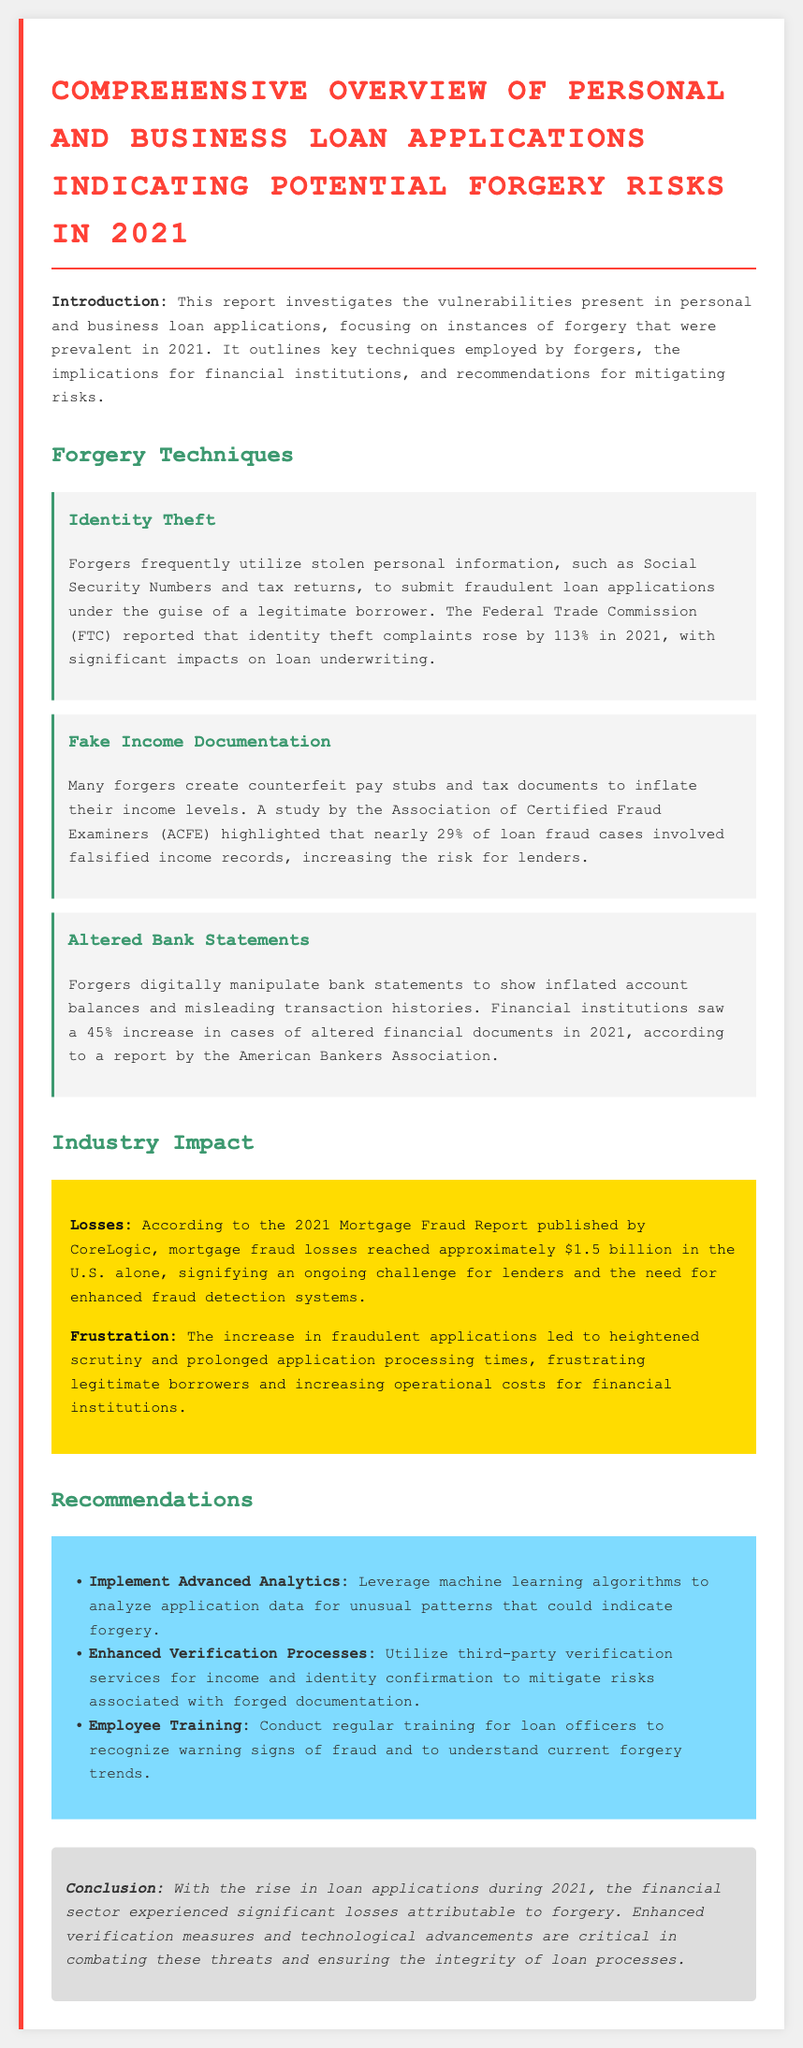What is the title of the report? The title is stated in the document as "Comprehensive Overview of Personal and Business Loan Applications Indicating Potential Forgery Risks in 2021."
Answer: Comprehensive Overview of Personal and Business Loan Applications Indicating Potential Forgery Risks in 2021 What percentage of loan fraud cases involved falsified income records? The report states that nearly 29% of loan fraud cases involved falsified income records according to a study by the Association of Certified Fraud Examiners (ACFE).
Answer: 29% What year did identity theft complaints rise by 113%? The document mentions that identity theft complaints rose by 113% in 2021.
Answer: 2021 How much did mortgage fraud losses reach in the U.S. in 2021? The report cites that mortgage fraud losses reached approximately $1.5 billion in the U.S. alone according to the 2021 Mortgage Fraud Report published by CoreLogic.
Answer: $1.5 billion What type of training is recommended for loan officers? The document recommends conducting regular training for loan officers to recognize warning signs of fraud and understand current forgery trends.
Answer: Regular training What is one of the recommended techniques to analyze application data? The report suggests leveraging machine learning algorithms as one of the techniques to analyze application data for unusual patterns that could indicate forgery.
Answer: Machine learning algorithms Which organization reported a significant increase in cases of altered financial documents in 2021? The American Bankers Association reported a 45% increase in cases of altered financial documents in 2021.
Answer: American Bankers Association What does the conclusion emphasize as critical in combating forgery threats? The conclusion emphasizes that enhanced verification measures and technological advancements are critical in combating forgery threats.
Answer: Enhanced verification measures 